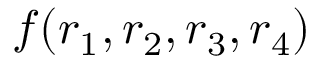<formula> <loc_0><loc_0><loc_500><loc_500>f ( r _ { 1 } , r _ { 2 } , r _ { 3 } , r _ { 4 } )</formula> 